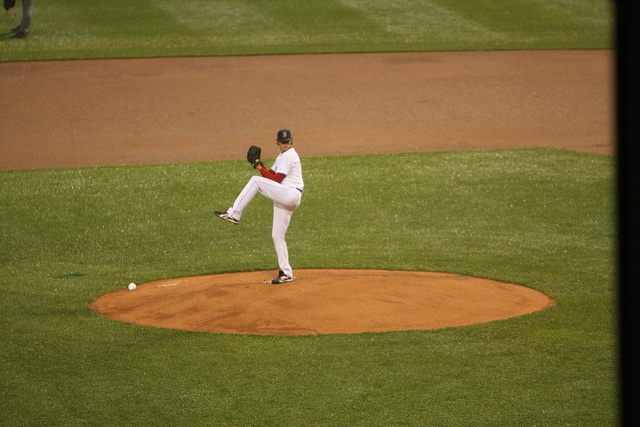Describe the objects in this image and their specific colors. I can see people in darkgreen, lightgray, darkgray, and black tones, baseball glove in darkgreen, black, and olive tones, sports ball in darkgreen, beige, tan, brown, and gray tones, and sports ball in darkgreen, beige, tan, and gray tones in this image. 